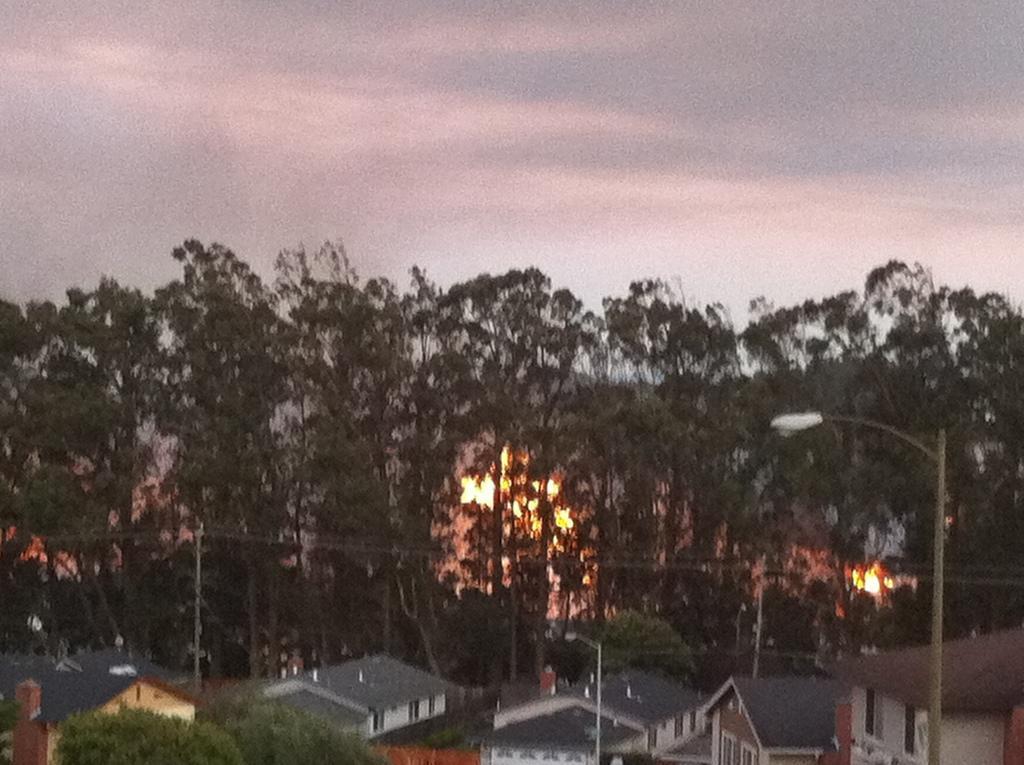How would you summarize this image in a sentence or two? In the foreground of the image we can see a group of buildings with roofs, light poles. In the background, we can see poles with some cables, group of trees and the cloudy sky. 